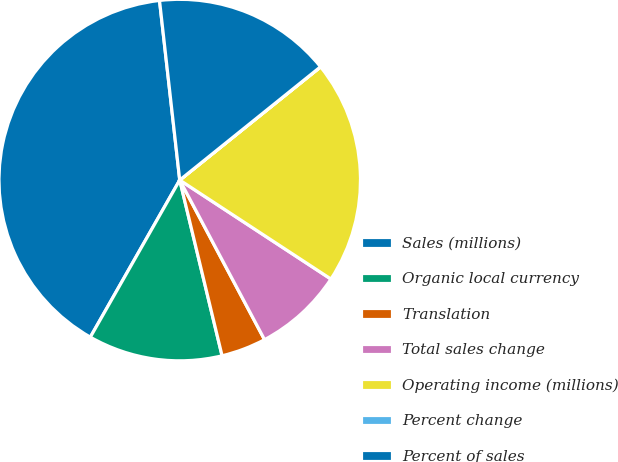<chart> <loc_0><loc_0><loc_500><loc_500><pie_chart><fcel>Sales (millions)<fcel>Organic local currency<fcel>Translation<fcel>Total sales change<fcel>Operating income (millions)<fcel>Percent change<fcel>Percent of sales<nl><fcel>39.98%<fcel>12.0%<fcel>4.01%<fcel>8.0%<fcel>20.0%<fcel>0.01%<fcel>16.0%<nl></chart> 